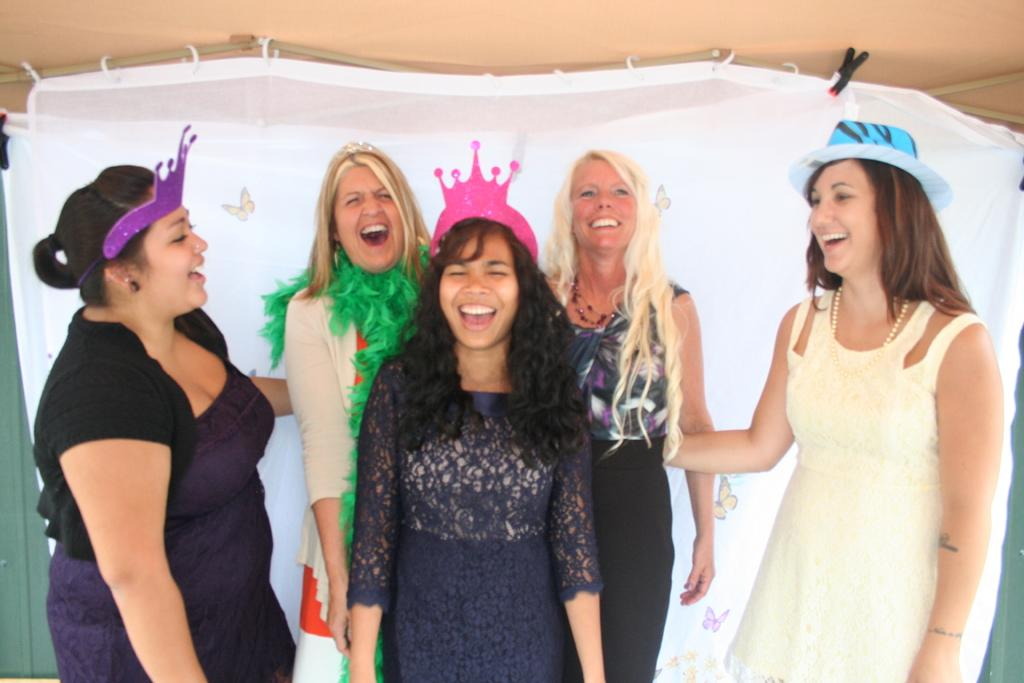How many people are in the image? There are a few ladies in the image. What are the ladies doing in the image? The ladies are laughing. What type of apparel are the boys wearing in the image? There are no boys present in the image; it only features a few ladies. 